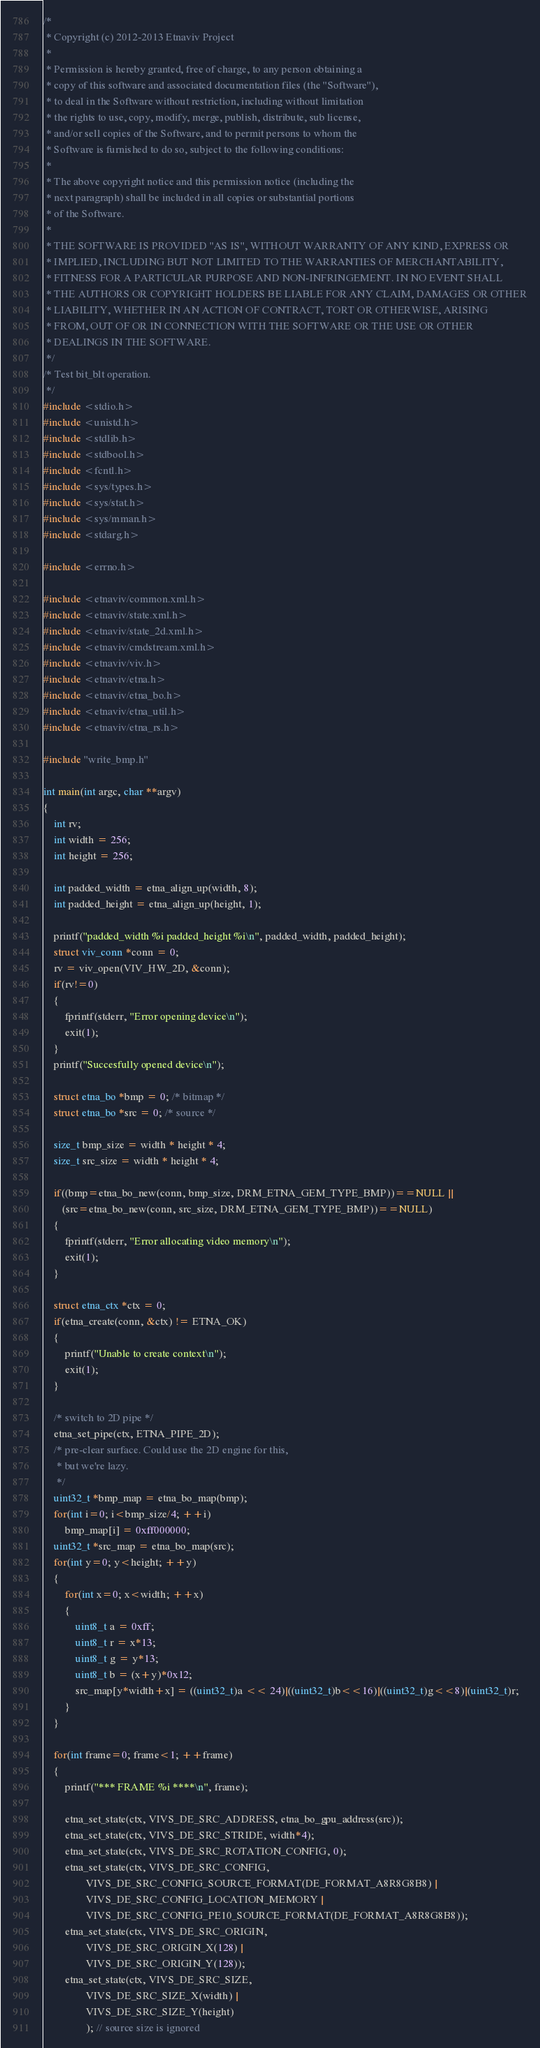Convert code to text. <code><loc_0><loc_0><loc_500><loc_500><_C_>/*
 * Copyright (c) 2012-2013 Etnaviv Project
 *
 * Permission is hereby granted, free of charge, to any person obtaining a
 * copy of this software and associated documentation files (the "Software"),
 * to deal in the Software without restriction, including without limitation
 * the rights to use, copy, modify, merge, publish, distribute, sub license,
 * and/or sell copies of the Software, and to permit persons to whom the
 * Software is furnished to do so, subject to the following conditions:
 *
 * The above copyright notice and this permission notice (including the
 * next paragraph) shall be included in all copies or substantial portions
 * of the Software.
 *
 * THE SOFTWARE IS PROVIDED "AS IS", WITHOUT WARRANTY OF ANY KIND, EXPRESS OR
 * IMPLIED, INCLUDING BUT NOT LIMITED TO THE WARRANTIES OF MERCHANTABILITY,
 * FITNESS FOR A PARTICULAR PURPOSE AND NON-INFRINGEMENT. IN NO EVENT SHALL
 * THE AUTHORS OR COPYRIGHT HOLDERS BE LIABLE FOR ANY CLAIM, DAMAGES OR OTHER
 * LIABILITY, WHETHER IN AN ACTION OF CONTRACT, TORT OR OTHERWISE, ARISING
 * FROM, OUT OF OR IN CONNECTION WITH THE SOFTWARE OR THE USE OR OTHER
 * DEALINGS IN THE SOFTWARE.
 */
/* Test bit_blt operation.
 */
#include <stdio.h>
#include <unistd.h>
#include <stdlib.h>
#include <stdbool.h>
#include <fcntl.h>
#include <sys/types.h>
#include <sys/stat.h>
#include <sys/mman.h>
#include <stdarg.h>

#include <errno.h>

#include <etnaviv/common.xml.h>
#include <etnaviv/state.xml.h>
#include <etnaviv/state_2d.xml.h>
#include <etnaviv/cmdstream.xml.h>
#include <etnaviv/viv.h>
#include <etnaviv/etna.h>
#include <etnaviv/etna_bo.h>
#include <etnaviv/etna_util.h>
#include <etnaviv/etna_rs.h>

#include "write_bmp.h"

int main(int argc, char **argv)
{
    int rv;
    int width = 256;
    int height = 256;
    
    int padded_width = etna_align_up(width, 8);
    int padded_height = etna_align_up(height, 1);
    
    printf("padded_width %i padded_height %i\n", padded_width, padded_height);
    struct viv_conn *conn = 0;
    rv = viv_open(VIV_HW_2D, &conn);
    if(rv!=0)
    {
        fprintf(stderr, "Error opening device\n");
        exit(1);
    }
    printf("Succesfully opened device\n");
    
    struct etna_bo *bmp = 0; /* bitmap */
    struct etna_bo *src = 0; /* source */

    size_t bmp_size = width * height * 4;
    size_t src_size = width * height * 4;

    if((bmp=etna_bo_new(conn, bmp_size, DRM_ETNA_GEM_TYPE_BMP))==NULL ||
       (src=etna_bo_new(conn, src_size, DRM_ETNA_GEM_TYPE_BMP))==NULL)
    {
        fprintf(stderr, "Error allocating video memory\n");
        exit(1);
    }

    struct etna_ctx *ctx = 0;
    if(etna_create(conn, &ctx) != ETNA_OK)
    {
        printf("Unable to create context\n");
        exit(1);
    }

    /* switch to 2D pipe */
    etna_set_pipe(ctx, ETNA_PIPE_2D);
    /* pre-clear surface. Could use the 2D engine for this,
     * but we're lazy.
     */
    uint32_t *bmp_map = etna_bo_map(bmp);
    for(int i=0; i<bmp_size/4; ++i)
        bmp_map[i] = 0xff000000;
    uint32_t *src_map = etna_bo_map(src);
    for(int y=0; y<height; ++y)
    {
        for(int x=0; x<width; ++x)
        {
            uint8_t a = 0xff;
            uint8_t r = x*13;
            uint8_t g = y*13;
            uint8_t b = (x+y)*0x12;
            src_map[y*width+x] = ((uint32_t)a << 24)|((uint32_t)b<<16)|((uint32_t)g<<8)|(uint32_t)r;
        }
    }

    for(int frame=0; frame<1; ++frame)
    {
        printf("*** FRAME %i ****\n", frame);

        etna_set_state(ctx, VIVS_DE_SRC_ADDRESS, etna_bo_gpu_address(src));
        etna_set_state(ctx, VIVS_DE_SRC_STRIDE, width*4);
        etna_set_state(ctx, VIVS_DE_SRC_ROTATION_CONFIG, 0);
        etna_set_state(ctx, VIVS_DE_SRC_CONFIG, 
                VIVS_DE_SRC_CONFIG_SOURCE_FORMAT(DE_FORMAT_A8R8G8B8) |
                VIVS_DE_SRC_CONFIG_LOCATION_MEMORY |
                VIVS_DE_SRC_CONFIG_PE10_SOURCE_FORMAT(DE_FORMAT_A8R8G8B8));
        etna_set_state(ctx, VIVS_DE_SRC_ORIGIN, 
                VIVS_DE_SRC_ORIGIN_X(128) |
                VIVS_DE_SRC_ORIGIN_Y(128));
        etna_set_state(ctx, VIVS_DE_SRC_SIZE, 
                VIVS_DE_SRC_SIZE_X(width) |
                VIVS_DE_SRC_SIZE_Y(height)
                ); // source size is ignored</code> 